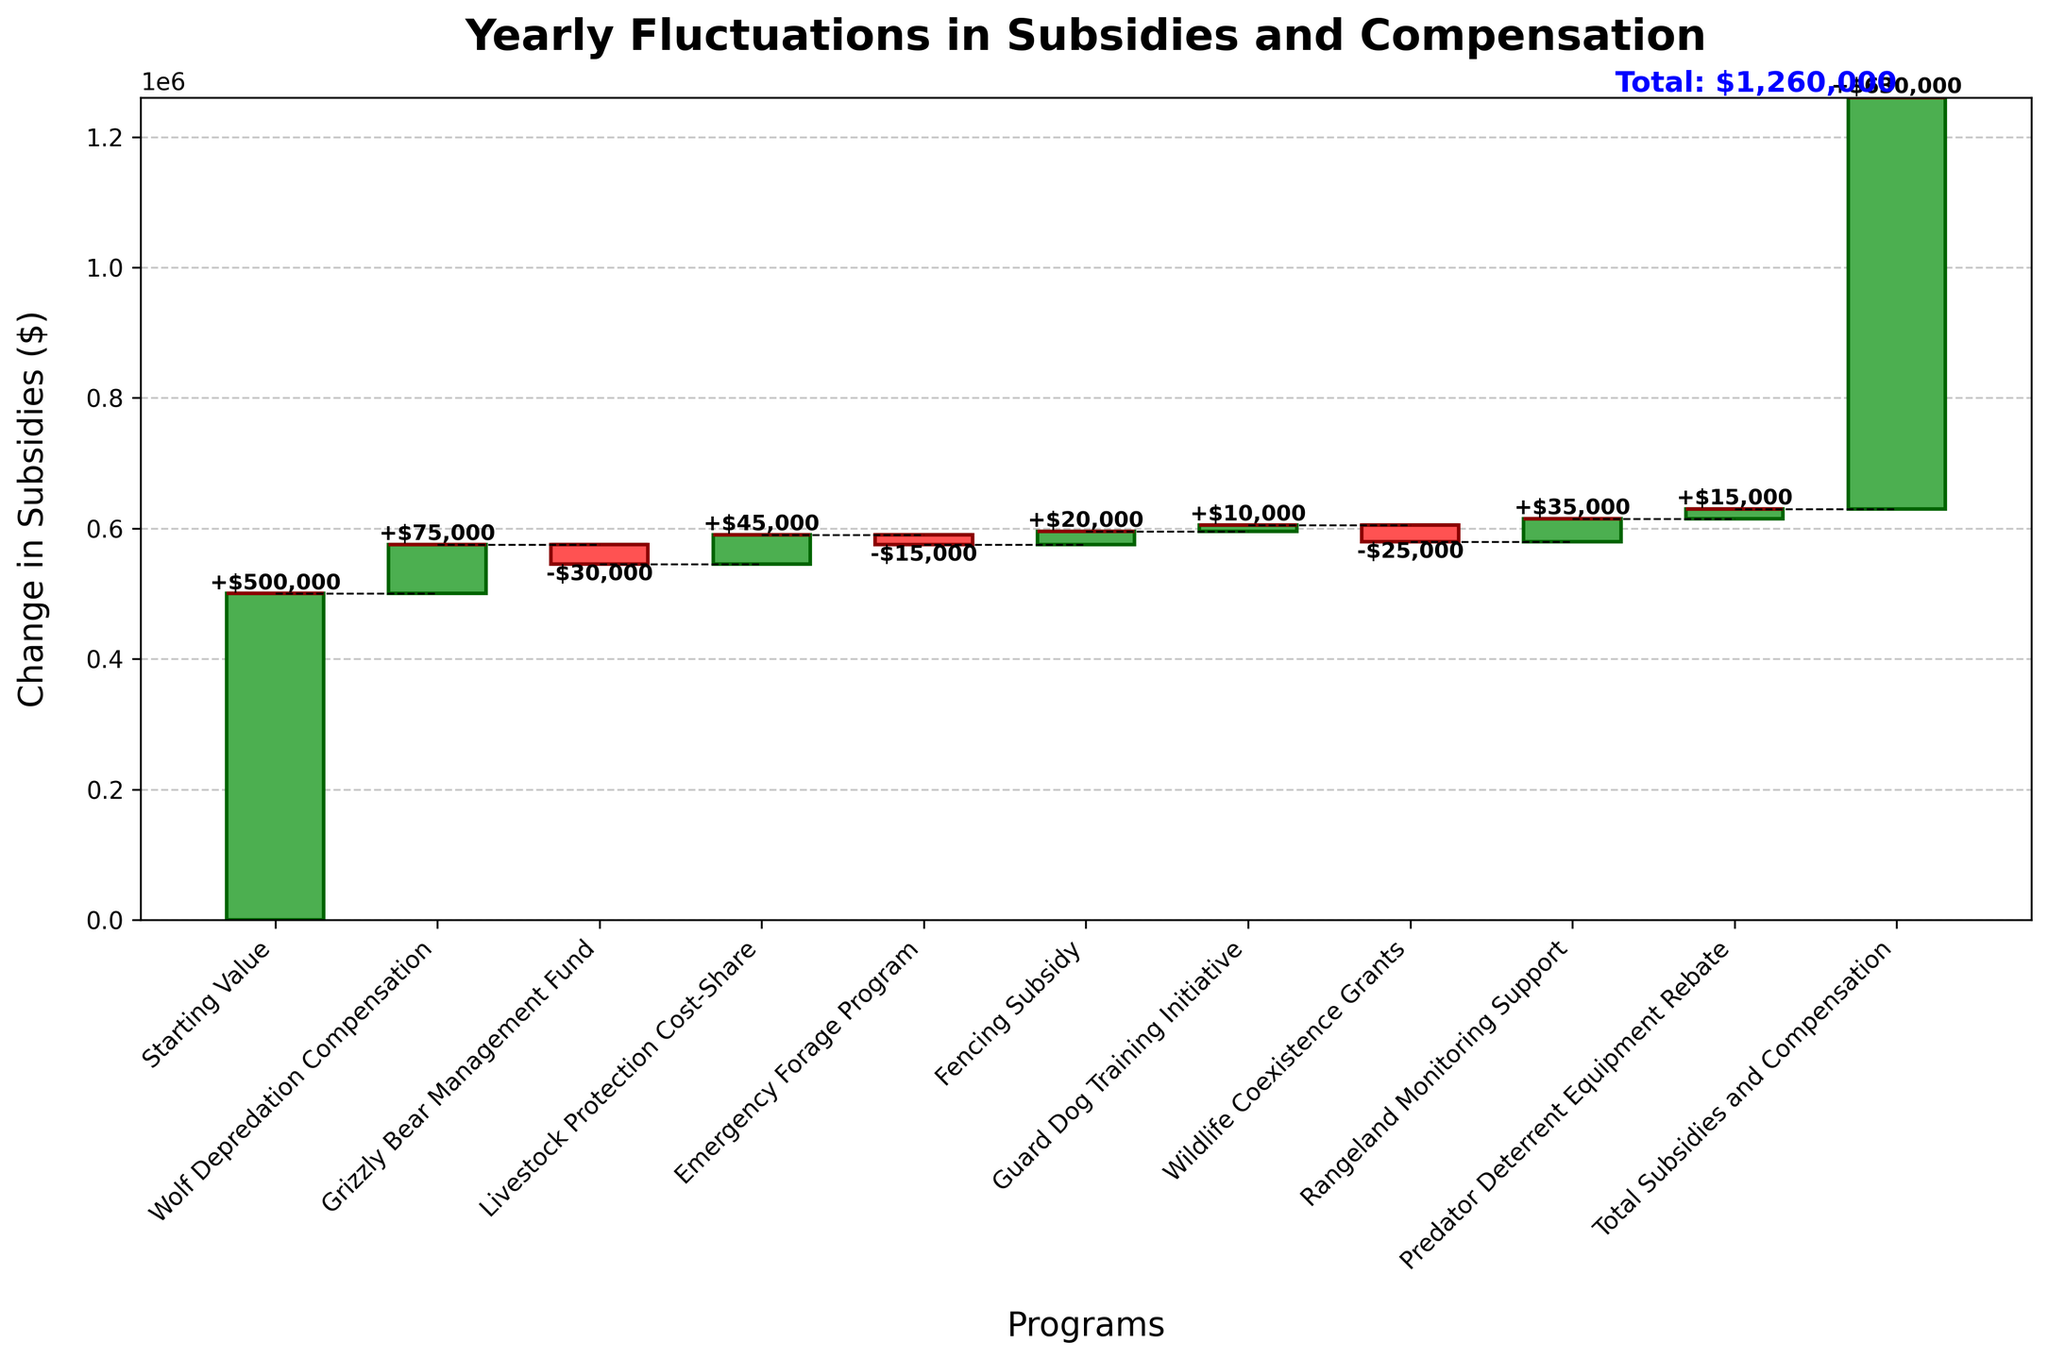What is the title of the chart? The title of the chart is displayed at the top of the figure, and it provides a summary of what the chart is about.
Answer: Yearly Fluctuations in Subsidies and Compensation Which program had the largest positive change in subsidies? By examining the height of the green bars, you can identify the program with the largest positive change in subsidies. This program has the tallest green bar.
Answer: Wolf Depredation Compensation How much does the Rangeland Monitoring Support program contribute to the total subsidies and compensation? Look at the height of the green bar for Rangeland Monitoring Support and the corresponding label. The value of $35000 is directly added to the total.
Answer: 35000 Which programs result in a negative change in subsidies? Identify the programs represented by red bars. The programs with red bars contribute to a negative change in subsidies.
Answer: Grizzly Bear Management Fund, Emergency Forage Program, Wildlife Coexistence Grants By how much did the Net Subsidy value change from the Starting Value to the Total Subsidies and Compensation? Subtract the Starting Value from the Total Subsidies and Compensation to get the net change ($630000 - $500000). 630000 - 500000 = 130000
Answer: 130000 Which program has the smallest positive change in subsidies? Among the green bars, identify the one with the shortest height, which corresponds to the smallest positive change.
Answer: Guard Dog Training Initiative What is the total positive change in subsidies from all programs? Add up all the positive changes: 75000 + 45000 + 20000 + 10000 + 35000 + 15000. 75000 + 45000 + 20000 + 10000 + 35000 + 15000 = 200000
Answer: 200000 Which program contributed the least to the overall change in subsidies and compensation? By comparing the heights of both green and red bars and their absolute values, identify the smallest contribution.
Answer: Emergency Forage Program Is the final total of subsidies and compensation greater than the starting value? Compare the Starting Value ($500000) with the Total Subsidies and Compensation ($630000) displayed at the end of the chart.
Answer: Yes 